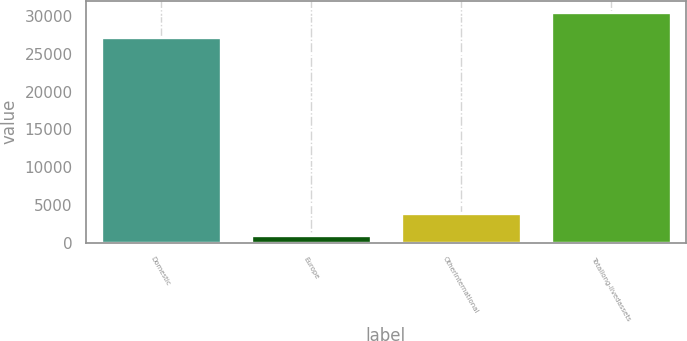Convert chart to OTSL. <chart><loc_0><loc_0><loc_500><loc_500><bar_chart><fcel>Domestic<fcel>Europe<fcel>OtherInternational<fcel>Totallong-livedassets<nl><fcel>27281<fcel>990<fcel>3943.4<fcel>30524<nl></chart> 